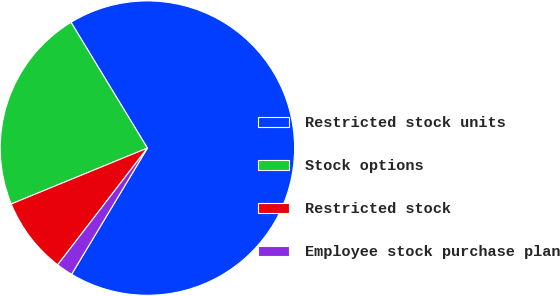Convert chart to OTSL. <chart><loc_0><loc_0><loc_500><loc_500><pie_chart><fcel>Restricted stock units<fcel>Stock options<fcel>Restricted stock<fcel>Employee stock purchase plan<nl><fcel>67.29%<fcel>22.51%<fcel>8.37%<fcel>1.82%<nl></chart> 